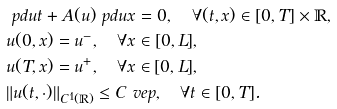Convert formula to latex. <formula><loc_0><loc_0><loc_500><loc_500>& \ p d u t + A ( u ) \ p d u x = 0 , \quad \forall ( t , x ) \in [ 0 , T ] \times \mathbb { R } , \\ & u ( 0 , x ) = u ^ { - } , \quad \forall x \in [ 0 , L ] , \\ & u ( T , x ) = u ^ { + } , \quad \forall x \in [ 0 , L ] , \\ & \| u ( t , \cdot ) \| _ { C ^ { 1 } ( \mathbb { R } ) } \leq C \ v e p , \quad \forall t \in [ 0 , T ] .</formula> 